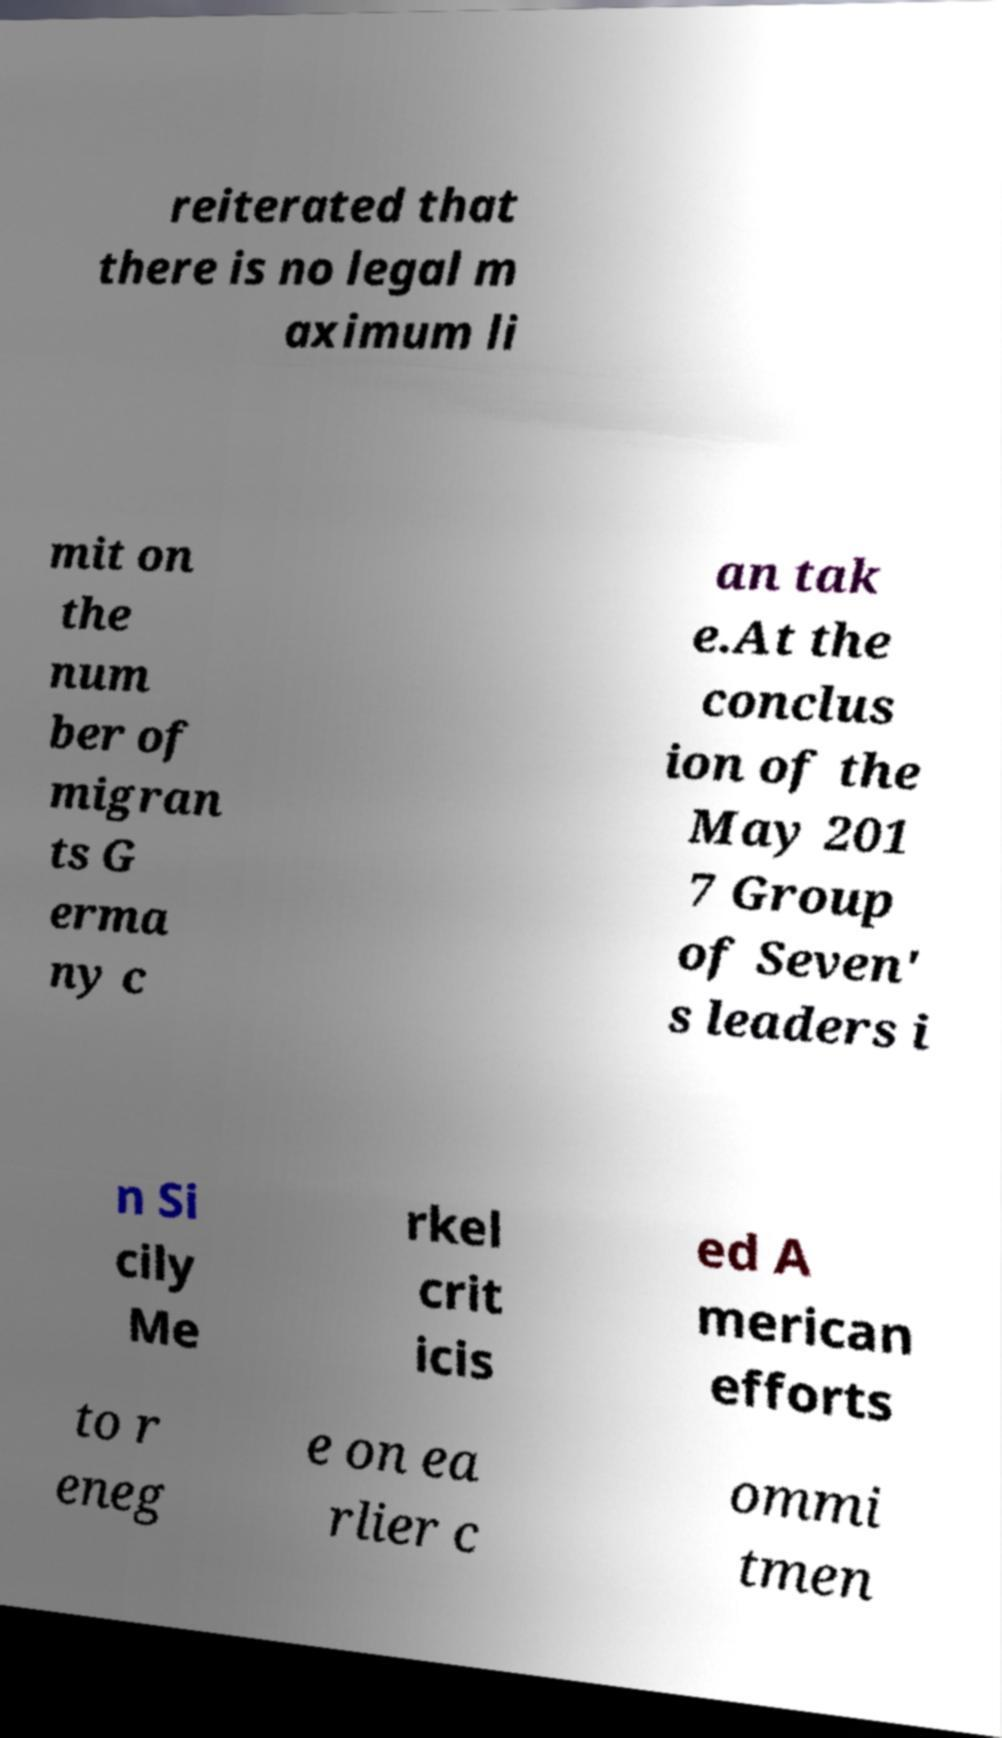I need the written content from this picture converted into text. Can you do that? reiterated that there is no legal m aximum li mit on the num ber of migran ts G erma ny c an tak e.At the conclus ion of the May 201 7 Group of Seven' s leaders i n Si cily Me rkel crit icis ed A merican efforts to r eneg e on ea rlier c ommi tmen 